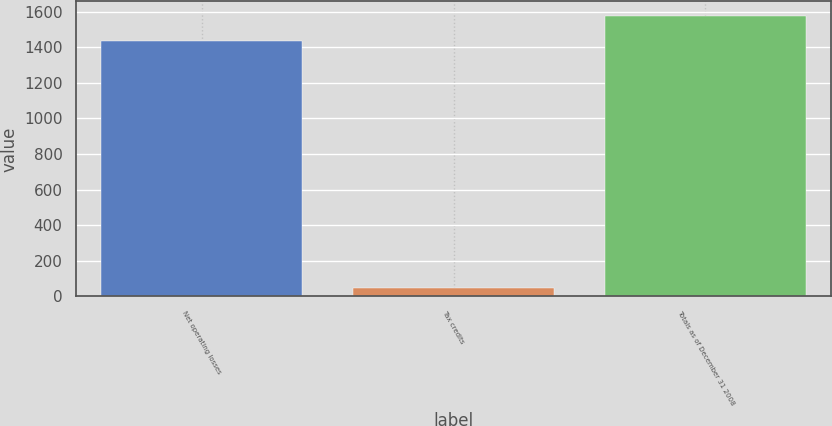Convert chart to OTSL. <chart><loc_0><loc_0><loc_500><loc_500><bar_chart><fcel>Net operating losses<fcel>Tax credits<fcel>Totals as of December 31 2008<nl><fcel>1435<fcel>49<fcel>1578.5<nl></chart> 